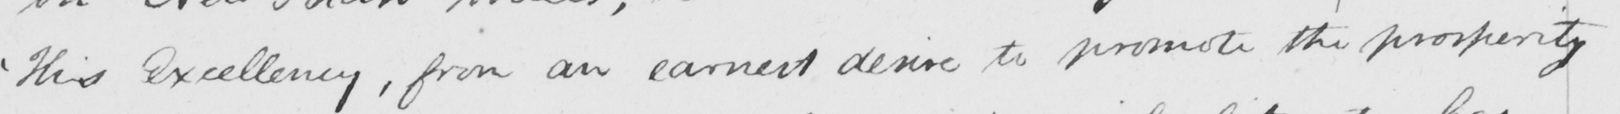Transcribe the text shown in this historical manuscript line. ' His Excellency , from an earnest desire to promote the prosperity 